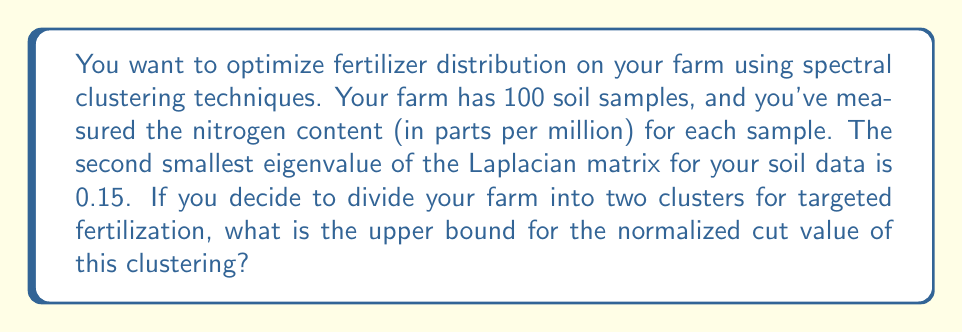Can you answer this question? To solve this problem, we'll use the properties of spectral clustering and the relationship between the normalized cut and the second smallest eigenvalue of the Laplacian matrix.

Step 1: Understand the relationship between normalized cut and eigenvalues.
The normalized cut value (NCut) for a two-way partition is upper bounded by the second smallest eigenvalue (λ₂) of the normalized Laplacian matrix:

$$ NCut \leq 2\lambda_2 $$

Step 2: Identify the given information.
- The second smallest eigenvalue (λ₂) of the Laplacian matrix is 0.15.

Step 3: Calculate the upper bound for the normalized cut.
$$ NCut \leq 2 \cdot 0.15 = 0.3 $$

Therefore, the upper bound for the normalized cut value of the two-cluster partition is 0.3.

This means that when you divide your farm into two clusters for targeted fertilization, the quality of the clustering (measured by the normalized cut) will be at most 0.3. A lower value indicates a better clustering, so this upper bound suggests a potentially good separation of your farm into two distinct regions for optimized fertilizer distribution.
Answer: 0.3 